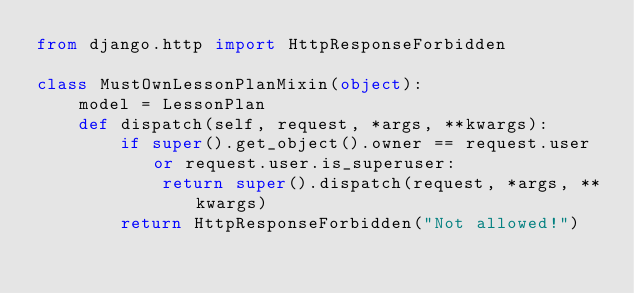<code> <loc_0><loc_0><loc_500><loc_500><_Python_>from django.http import HttpResponseForbidden

class MustOwnLessonPlanMixin(object):
    model = LessonPlan
    def dispatch(self, request, *args, **kwargs):
        if super().get_object().owner == request.user or request.user.is_superuser:
            return super().dispatch(request, *args, **kwargs)
        return HttpResponseForbidden("Not allowed!")</code> 